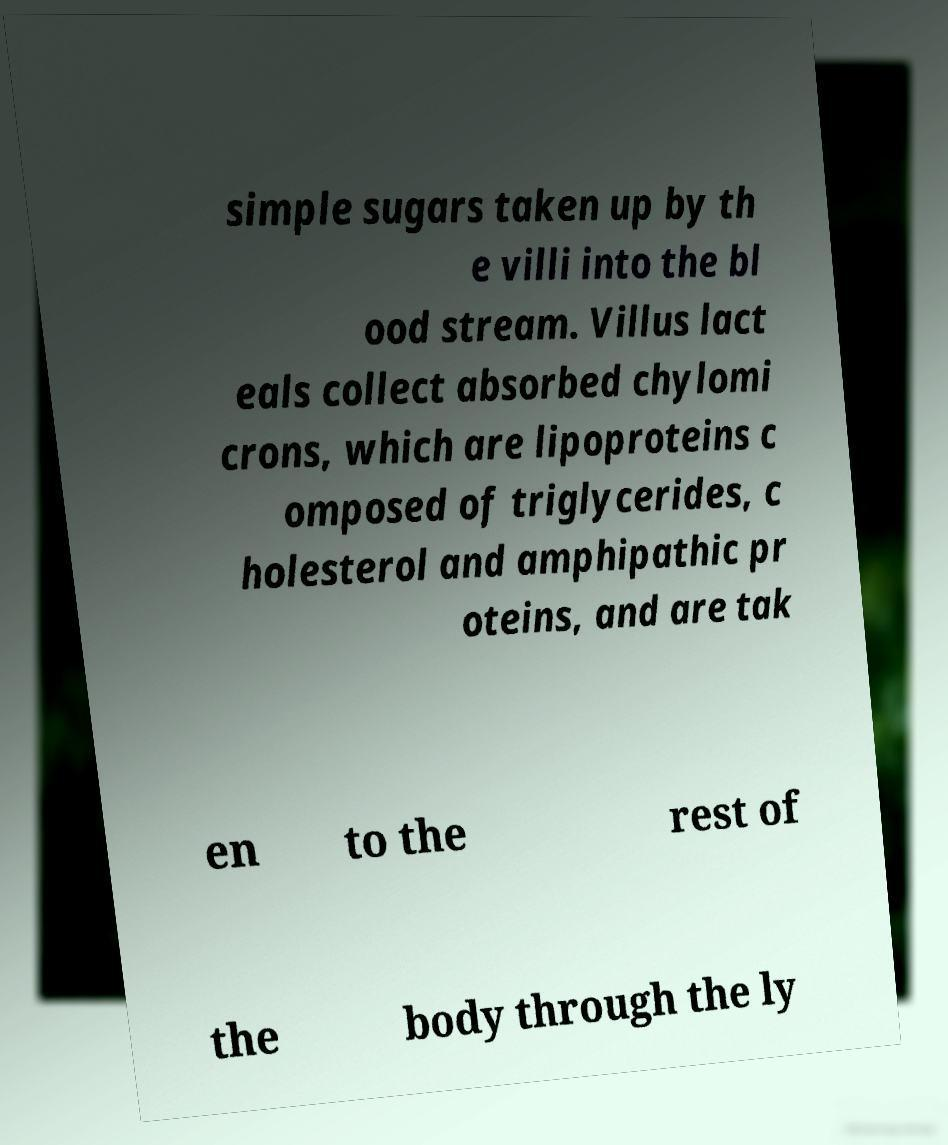Can you read and provide the text displayed in the image?This photo seems to have some interesting text. Can you extract and type it out for me? simple sugars taken up by th e villi into the bl ood stream. Villus lact eals collect absorbed chylomi crons, which are lipoproteins c omposed of triglycerides, c holesterol and amphipathic pr oteins, and are tak en to the rest of the body through the ly 